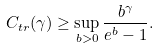Convert formula to latex. <formula><loc_0><loc_0><loc_500><loc_500>C _ { t r } ( \gamma ) \geq \sup _ { b > 0 } \frac { b ^ { \gamma } } { e ^ { b } - 1 } .</formula> 